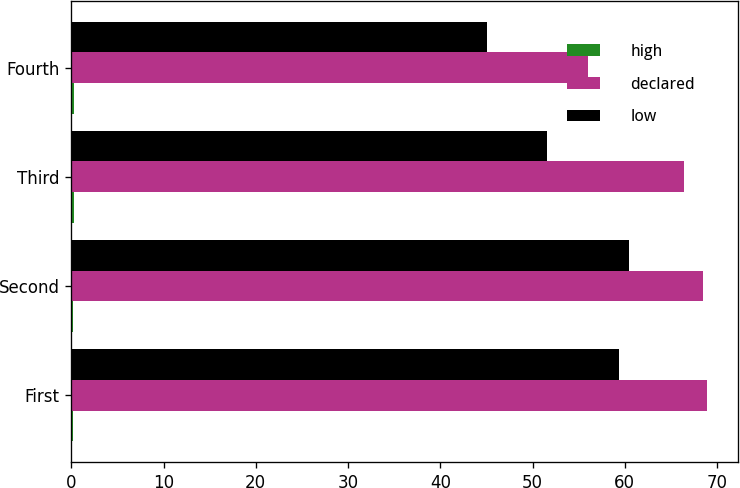<chart> <loc_0><loc_0><loc_500><loc_500><stacked_bar_chart><ecel><fcel>First<fcel>Second<fcel>Third<fcel>Fourth<nl><fcel>high<fcel>0.22<fcel>0.22<fcel>0.24<fcel>0.24<nl><fcel>declared<fcel>68.87<fcel>68.44<fcel>66.43<fcel>56.05<nl><fcel>low<fcel>59.33<fcel>60.5<fcel>51.51<fcel>45.04<nl></chart> 